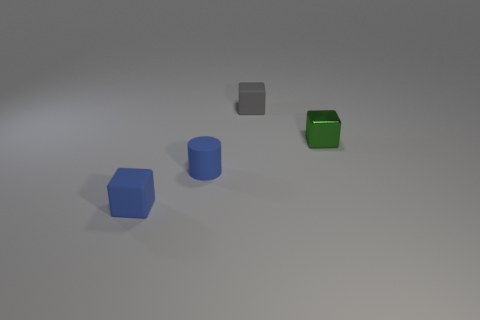How many gray things are either blocks or tiny shiny blocks?
Give a very brief answer. 1. Do the cylinder and the object that is behind the tiny metallic thing have the same color?
Offer a very short reply. No. What number of other things are there of the same color as the small matte cylinder?
Ensure brevity in your answer.  1. Are there fewer small purple blocks than blue blocks?
Give a very brief answer. Yes. There is a tiny blue thing that is right of the small cube on the left side of the gray block; how many green objects are behind it?
Your answer should be very brief. 1. There is a small thing behind the green object; is its shape the same as the tiny green shiny object?
Your answer should be very brief. Yes. There is a green thing that is the same shape as the tiny gray object; what is its material?
Your answer should be compact. Metal. Are there any small green metallic cubes?
Your answer should be compact. Yes. What is the small green object that is in front of the tiny rubber cube on the right side of the small rubber thing in front of the cylinder made of?
Give a very brief answer. Metal. There is a gray matte object; does it have the same shape as the tiny blue rubber thing that is in front of the small blue matte cylinder?
Ensure brevity in your answer.  Yes. 